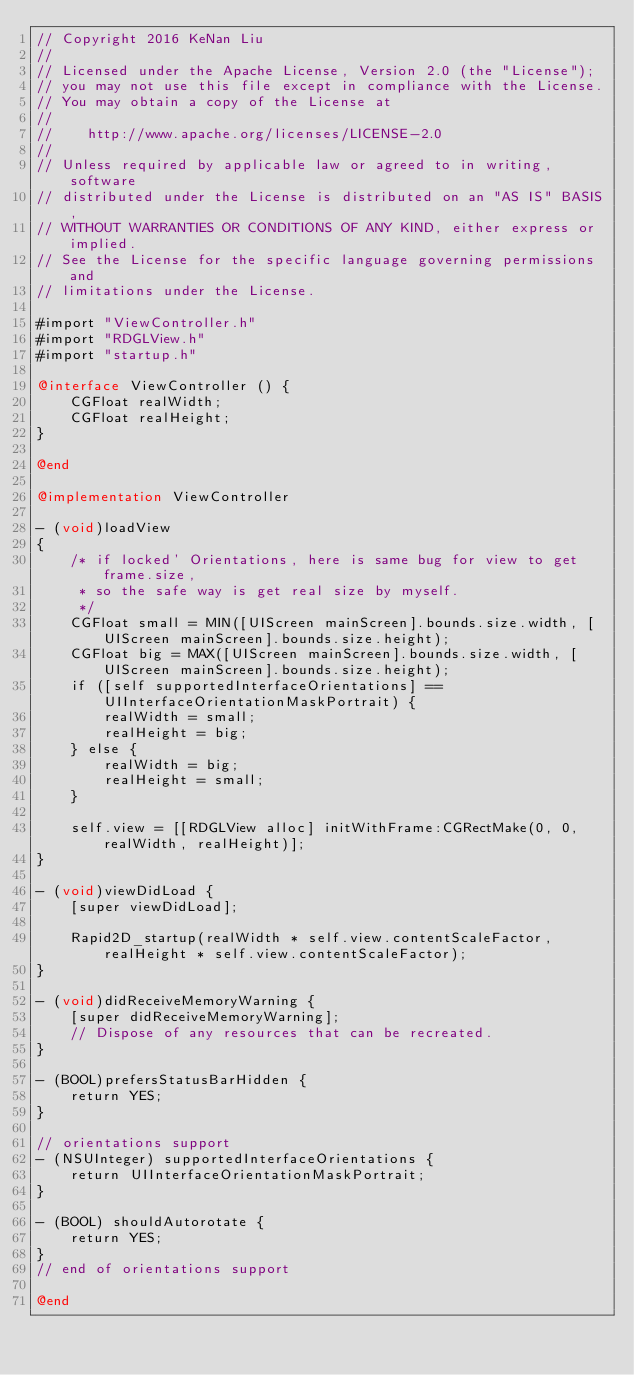Convert code to text. <code><loc_0><loc_0><loc_500><loc_500><_ObjectiveC_>// Copyright 2016 KeNan Liu
//
// Licensed under the Apache License, Version 2.0 (the "License");
// you may not use this file except in compliance with the License.
// You may obtain a copy of the License at
//
//    http://www.apache.org/licenses/LICENSE-2.0
//
// Unless required by applicable law or agreed to in writing, software
// distributed under the License is distributed on an "AS IS" BASIS,
// WITHOUT WARRANTIES OR CONDITIONS OF ANY KIND, either express or implied.
// See the License for the specific language governing permissions and
// limitations under the License.

#import "ViewController.h"
#import "RDGLView.h"
#import "startup.h"

@interface ViewController () {
    CGFloat realWidth;
    CGFloat realHeight;
}

@end

@implementation ViewController

- (void)loadView
{
    /* if locked' Orientations, here is same bug for view to get frame.size,
     * so the safe way is get real size by myself.
     */
    CGFloat small = MIN([UIScreen mainScreen].bounds.size.width, [UIScreen mainScreen].bounds.size.height);
    CGFloat big = MAX([UIScreen mainScreen].bounds.size.width, [UIScreen mainScreen].bounds.size.height);
    if ([self supportedInterfaceOrientations] == UIInterfaceOrientationMaskPortrait) {
        realWidth = small;
        realHeight = big;
    } else {
        realWidth = big;
        realHeight = small;
    }
    
    self.view = [[RDGLView alloc] initWithFrame:CGRectMake(0, 0, realWidth, realHeight)];
}

- (void)viewDidLoad {
    [super viewDidLoad];

    Rapid2D_startup(realWidth * self.view.contentScaleFactor, realHeight * self.view.contentScaleFactor);
}

- (void)didReceiveMemoryWarning {
    [super didReceiveMemoryWarning];
    // Dispose of any resources that can be recreated.
}

- (BOOL)prefersStatusBarHidden {
    return YES;
}

// orientations support
- (NSUInteger) supportedInterfaceOrientations {
    return UIInterfaceOrientationMaskPortrait;
}

- (BOOL) shouldAutorotate {
    return YES;
}
// end of orientations support

@end
</code> 